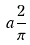<formula> <loc_0><loc_0><loc_500><loc_500>a \frac { 2 } { \pi }</formula> 